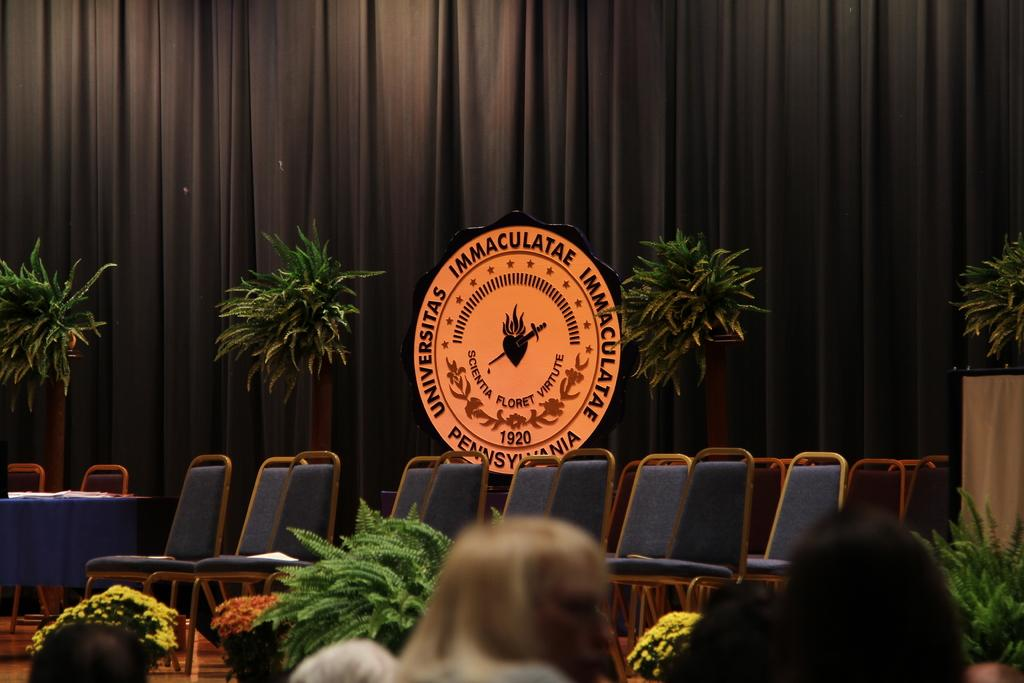What type of furniture is on the stage in the image? There are chairs on the stage in the image. What can be seen on the chairs or near them? There is an orange logo in the image. What type of natural elements are present in the image? There are plants in the image. What color is the curtain in the background of the image? There is a brown color curtain in the background of the image. What type of fowl can be seen in the image? There is no fowl present in the image. What happens when the orange logo bursts in the image? There is no indication of the orange logo bursting in the image. 